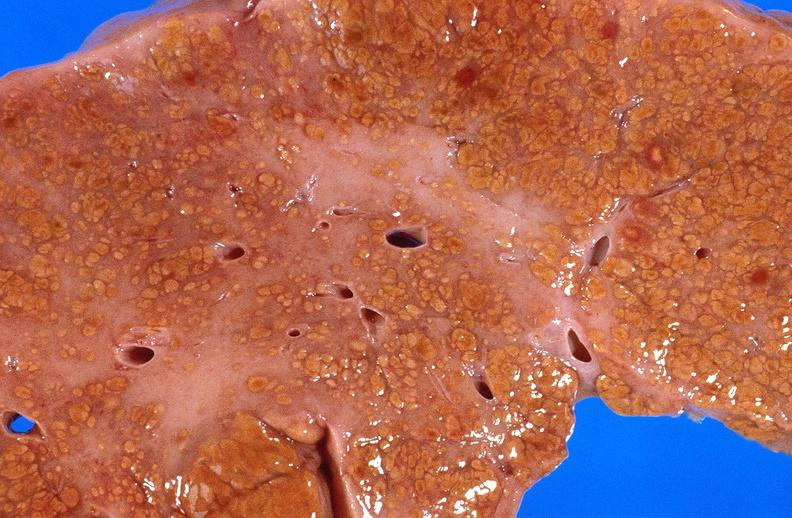what is present?
Answer the question using a single word or phrase. Hepatobiliary 